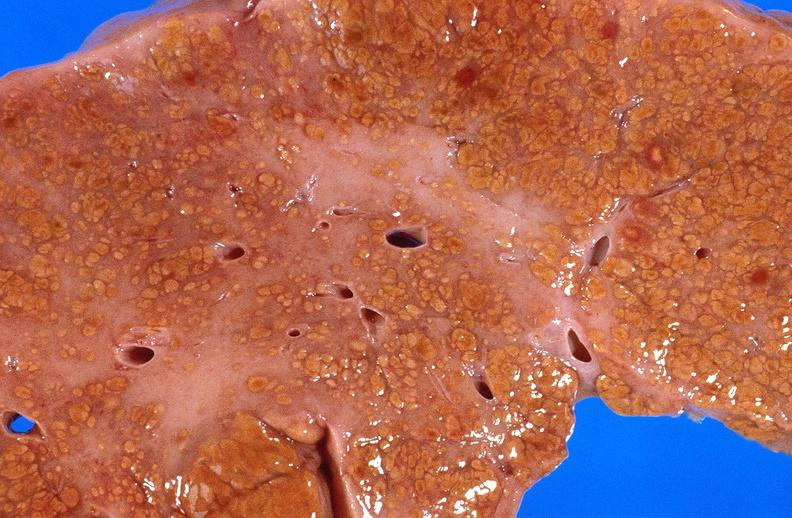what is present?
Answer the question using a single word or phrase. Hepatobiliary 